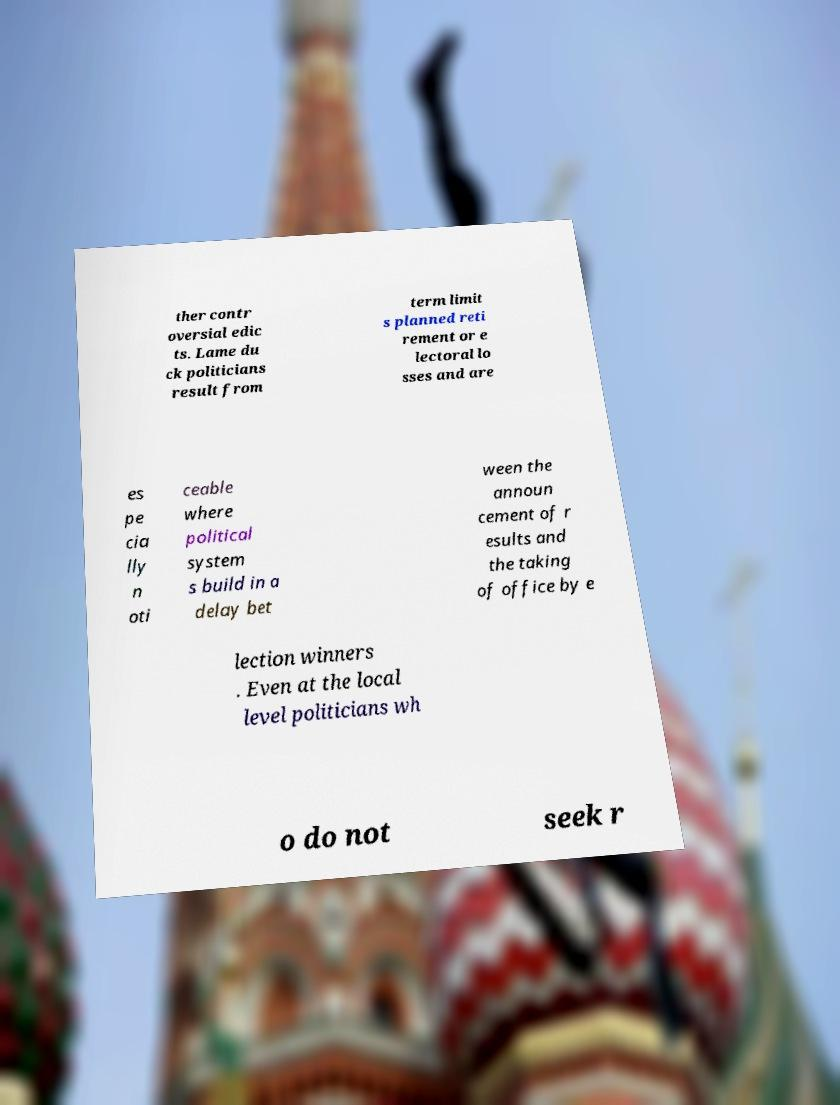Can you accurately transcribe the text from the provided image for me? ther contr oversial edic ts. Lame du ck politicians result from term limit s planned reti rement or e lectoral lo sses and are es pe cia lly n oti ceable where political system s build in a delay bet ween the announ cement of r esults and the taking of office by e lection winners . Even at the local level politicians wh o do not seek r 